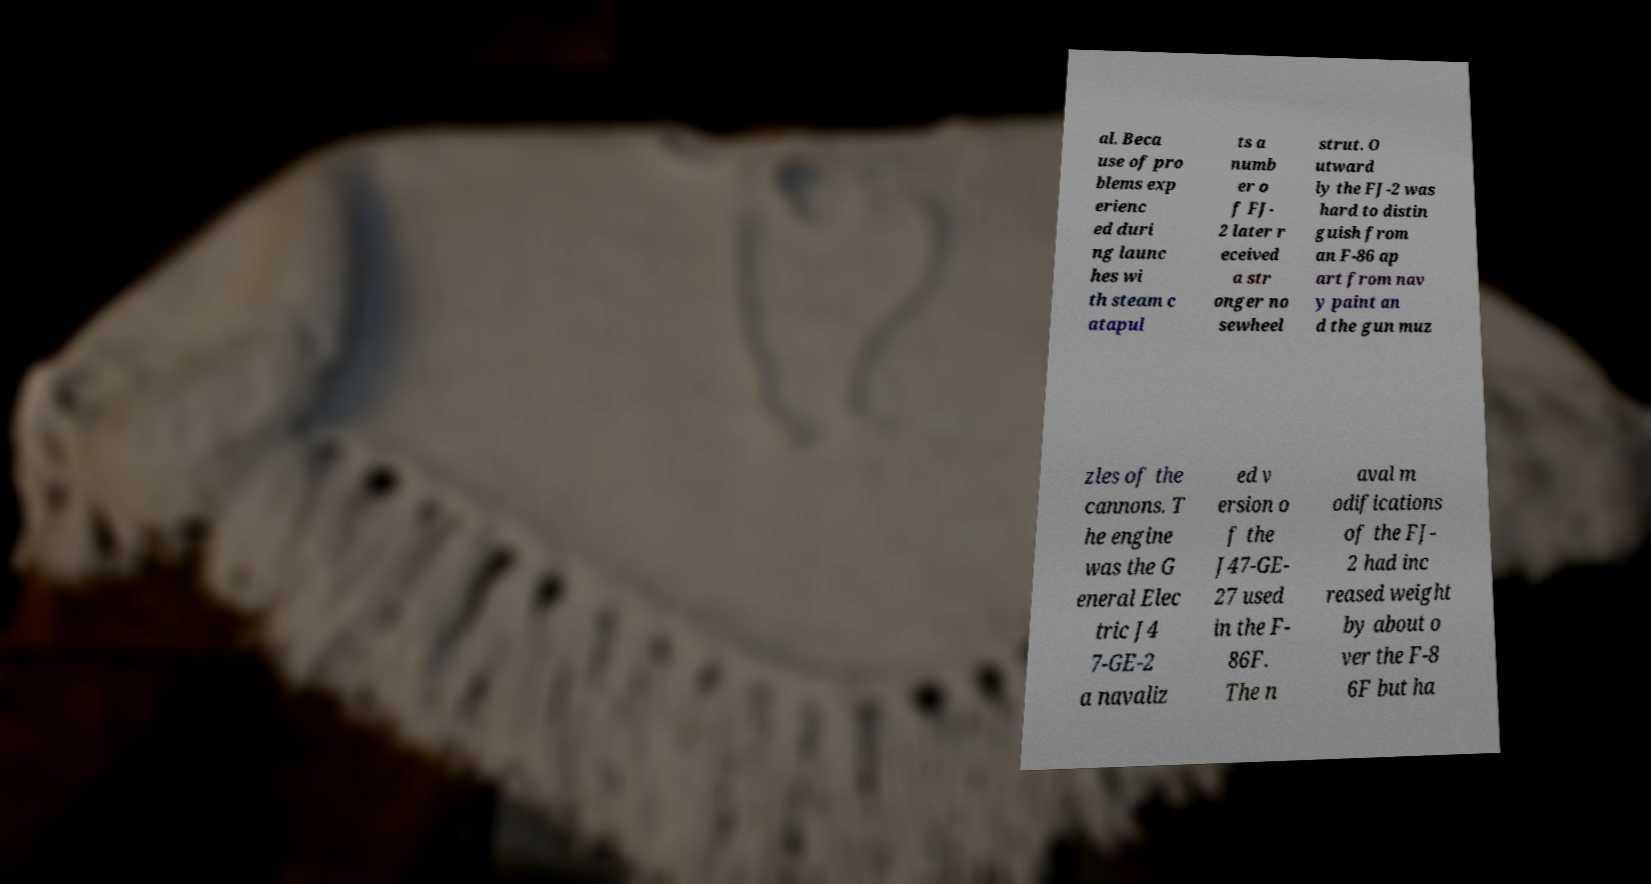Can you read and provide the text displayed in the image?This photo seems to have some interesting text. Can you extract and type it out for me? al. Beca use of pro blems exp erienc ed duri ng launc hes wi th steam c atapul ts a numb er o f FJ- 2 later r eceived a str onger no sewheel strut. O utward ly the FJ-2 was hard to distin guish from an F-86 ap art from nav y paint an d the gun muz zles of the cannons. T he engine was the G eneral Elec tric J4 7-GE-2 a navaliz ed v ersion o f the J47-GE- 27 used in the F- 86F. The n aval m odifications of the FJ- 2 had inc reased weight by about o ver the F-8 6F but ha 